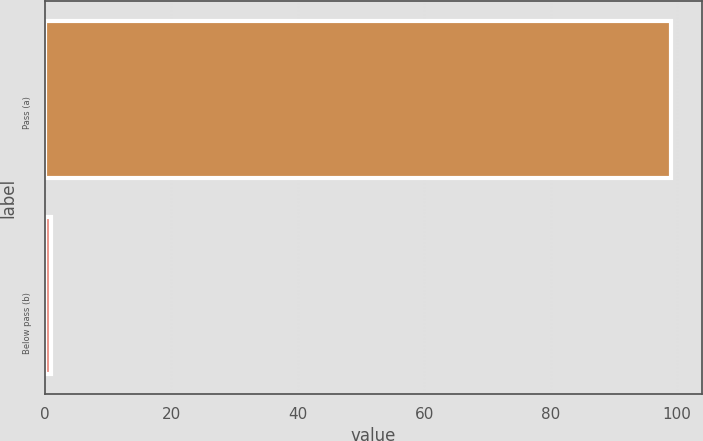Convert chart. <chart><loc_0><loc_0><loc_500><loc_500><bar_chart><fcel>Pass (a)<fcel>Below pass (b)<nl><fcel>99<fcel>1<nl></chart> 